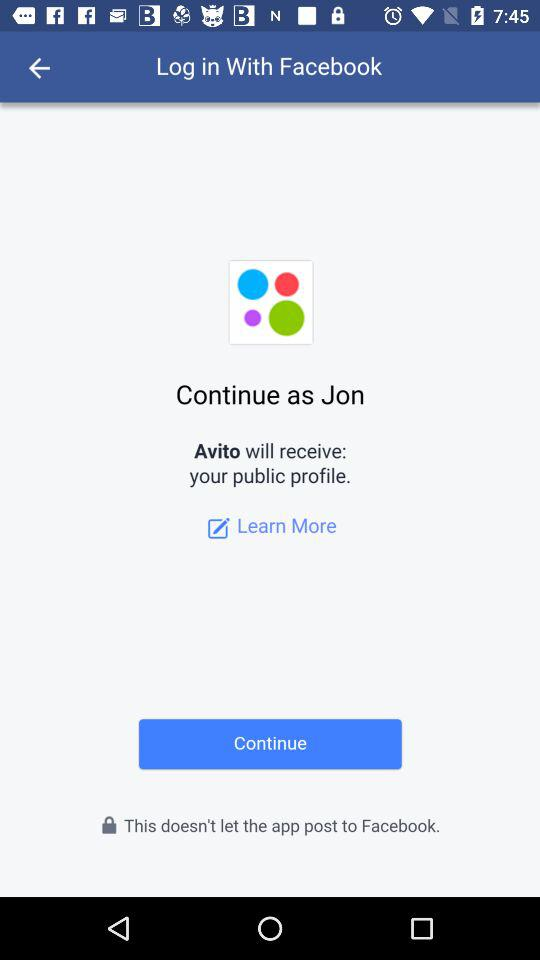What is the name of the user? The name of the user is Jon. 